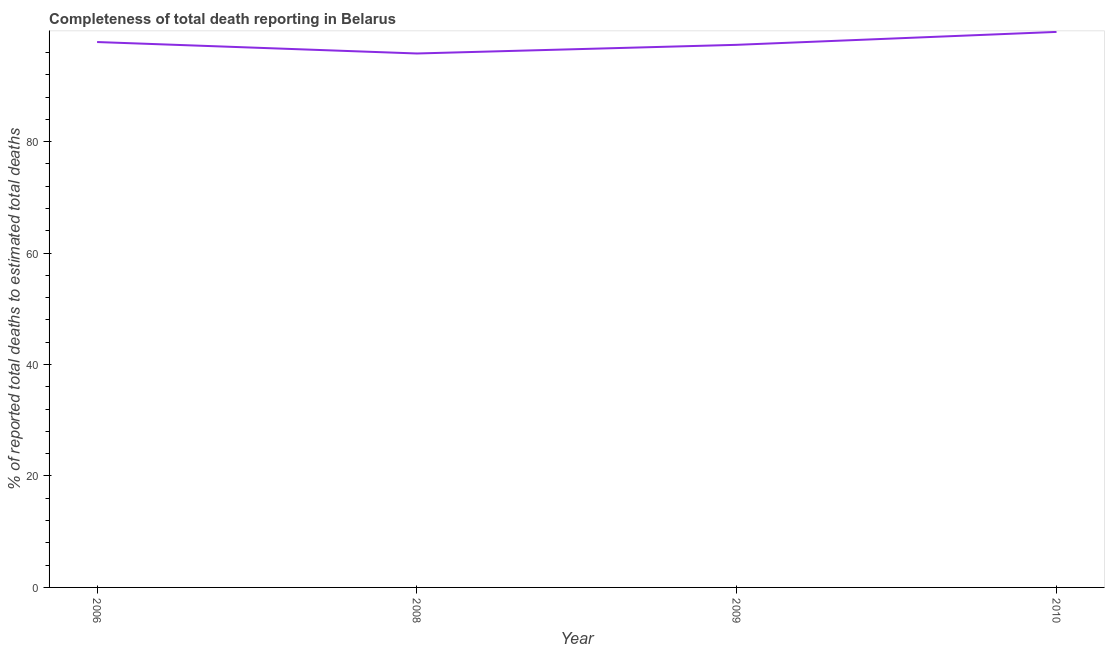What is the completeness of total death reports in 2009?
Provide a short and direct response. 97.39. Across all years, what is the maximum completeness of total death reports?
Give a very brief answer. 99.71. Across all years, what is the minimum completeness of total death reports?
Make the answer very short. 95.83. In which year was the completeness of total death reports maximum?
Keep it short and to the point. 2010. In which year was the completeness of total death reports minimum?
Offer a very short reply. 2008. What is the sum of the completeness of total death reports?
Keep it short and to the point. 390.82. What is the difference between the completeness of total death reports in 2009 and 2010?
Give a very brief answer. -2.32. What is the average completeness of total death reports per year?
Keep it short and to the point. 97.7. What is the median completeness of total death reports?
Offer a very short reply. 97.64. In how many years, is the completeness of total death reports greater than 64 %?
Your response must be concise. 4. What is the ratio of the completeness of total death reports in 2006 to that in 2010?
Provide a succinct answer. 0.98. What is the difference between the highest and the second highest completeness of total death reports?
Offer a terse response. 1.82. What is the difference between the highest and the lowest completeness of total death reports?
Your answer should be compact. 3.87. Are the values on the major ticks of Y-axis written in scientific E-notation?
Provide a short and direct response. No. Does the graph contain any zero values?
Provide a short and direct response. No. Does the graph contain grids?
Give a very brief answer. No. What is the title of the graph?
Offer a very short reply. Completeness of total death reporting in Belarus. What is the label or title of the Y-axis?
Offer a terse response. % of reported total deaths to estimated total deaths. What is the % of reported total deaths to estimated total deaths of 2006?
Ensure brevity in your answer.  97.89. What is the % of reported total deaths to estimated total deaths in 2008?
Offer a terse response. 95.83. What is the % of reported total deaths to estimated total deaths of 2009?
Give a very brief answer. 97.39. What is the % of reported total deaths to estimated total deaths of 2010?
Your answer should be very brief. 99.71. What is the difference between the % of reported total deaths to estimated total deaths in 2006 and 2008?
Offer a very short reply. 2.06. What is the difference between the % of reported total deaths to estimated total deaths in 2006 and 2009?
Give a very brief answer. 0.5. What is the difference between the % of reported total deaths to estimated total deaths in 2006 and 2010?
Your answer should be compact. -1.82. What is the difference between the % of reported total deaths to estimated total deaths in 2008 and 2009?
Your response must be concise. -1.56. What is the difference between the % of reported total deaths to estimated total deaths in 2008 and 2010?
Your answer should be very brief. -3.87. What is the difference between the % of reported total deaths to estimated total deaths in 2009 and 2010?
Make the answer very short. -2.32. What is the ratio of the % of reported total deaths to estimated total deaths in 2006 to that in 2008?
Keep it short and to the point. 1.02. What is the ratio of the % of reported total deaths to estimated total deaths in 2006 to that in 2009?
Offer a terse response. 1. What is the ratio of the % of reported total deaths to estimated total deaths in 2006 to that in 2010?
Give a very brief answer. 0.98. What is the ratio of the % of reported total deaths to estimated total deaths in 2008 to that in 2009?
Your answer should be very brief. 0.98. 